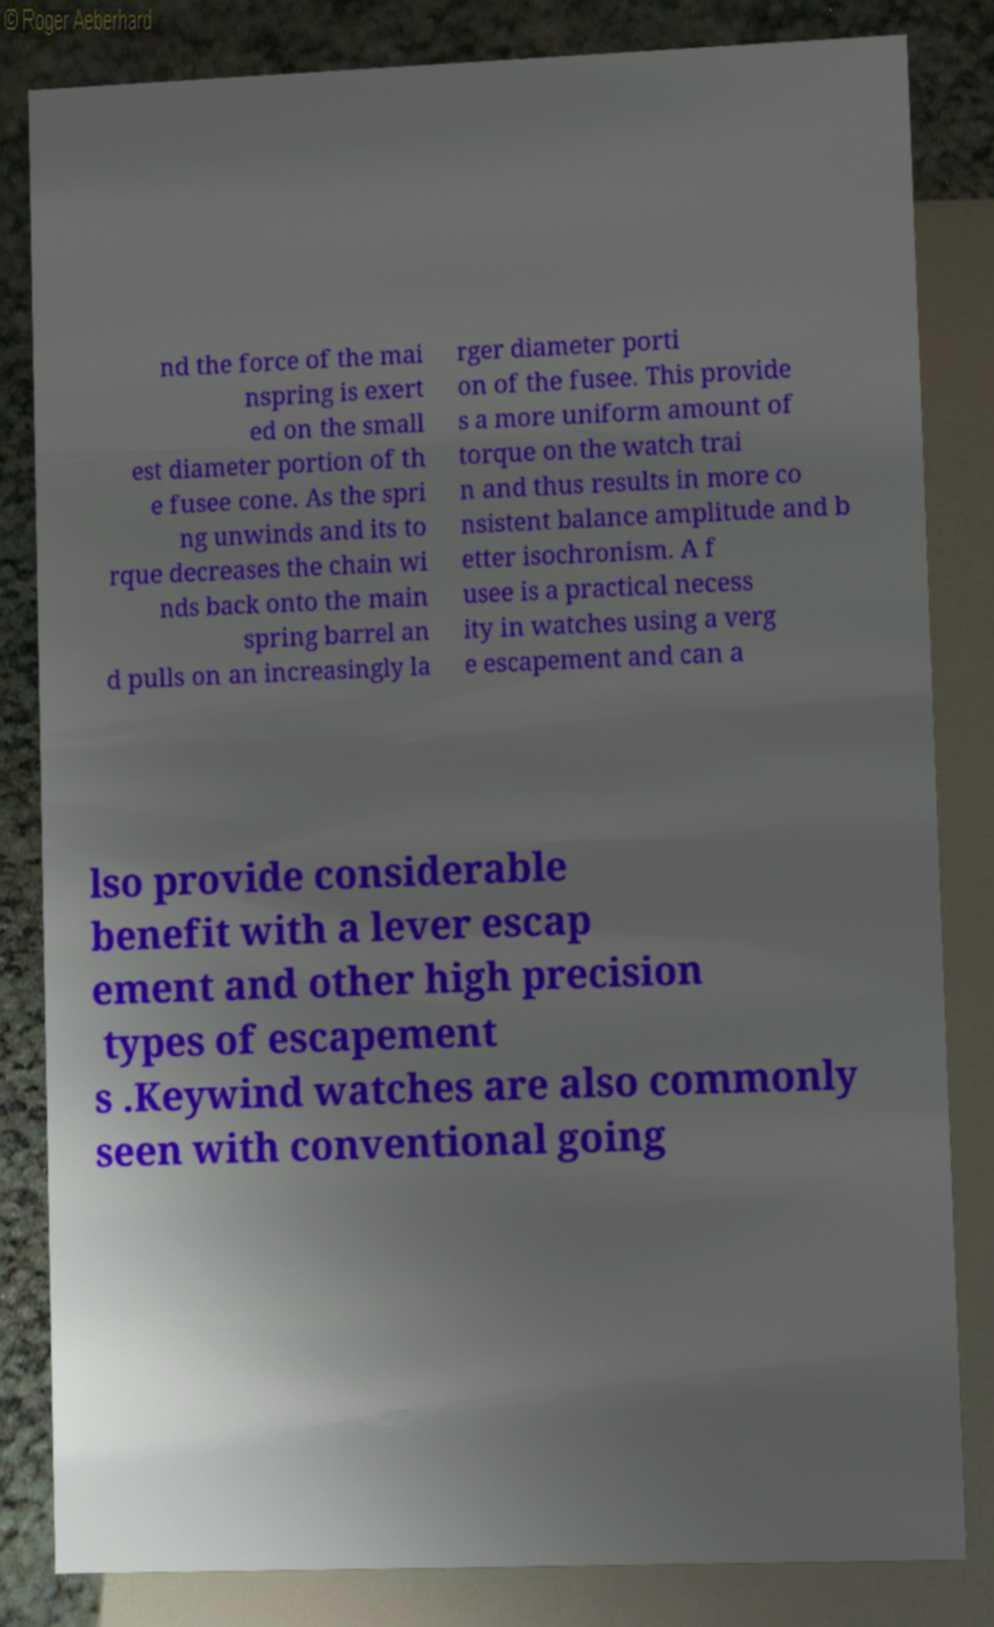For documentation purposes, I need the text within this image transcribed. Could you provide that? nd the force of the mai nspring is exert ed on the small est diameter portion of th e fusee cone. As the spri ng unwinds and its to rque decreases the chain wi nds back onto the main spring barrel an d pulls on an increasingly la rger diameter porti on of the fusee. This provide s a more uniform amount of torque on the watch trai n and thus results in more co nsistent balance amplitude and b etter isochronism. A f usee is a practical necess ity in watches using a verg e escapement and can a lso provide considerable benefit with a lever escap ement and other high precision types of escapement s .Keywind watches are also commonly seen with conventional going 